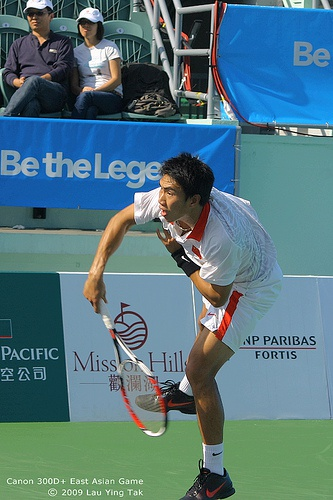Describe the objects in this image and their specific colors. I can see people in gray, black, and maroon tones, tennis racket in gray, darkgray, and white tones, handbag in gray, black, and darkgray tones, chair in gray, black, teal, and darkgray tones, and chair in gray, teal, and black tones in this image. 